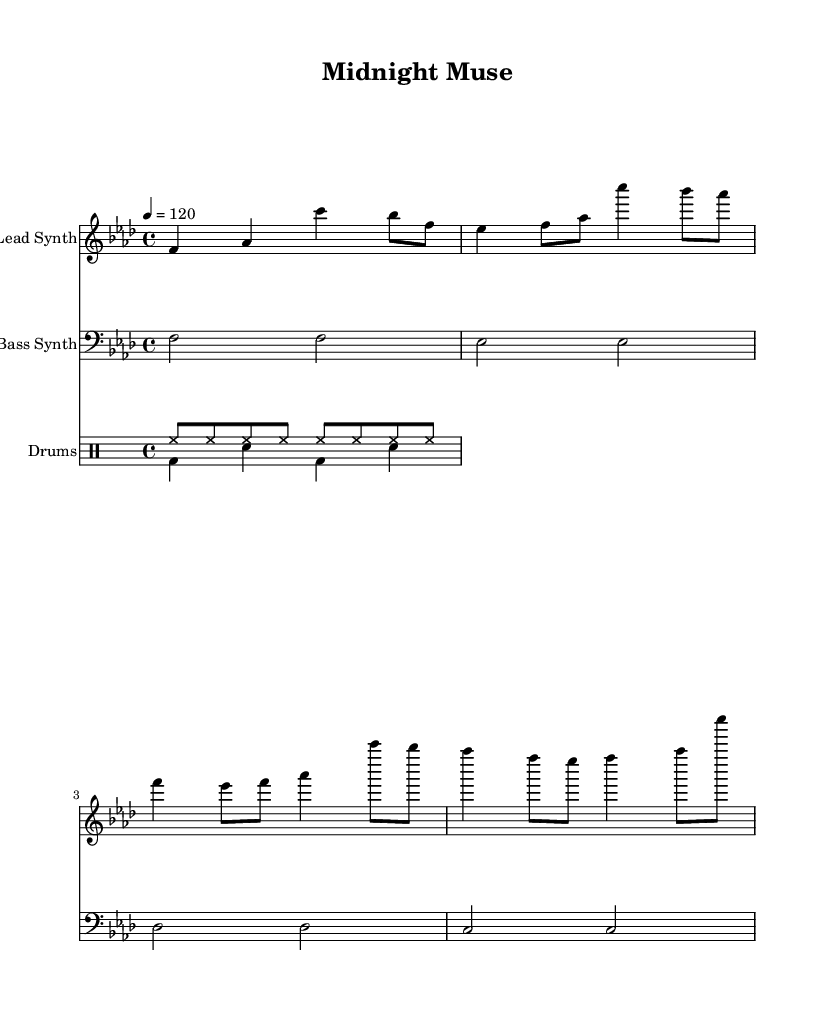what is the key signature of this music? The key signature indicates that the piece is in F minor, as it has four flats. These flats represent B flat, E flat, A flat, and D flat. F minor specifically has these flats in its key signature.
Answer: F minor what is the time signature of this music? The time signature is indicated as 4/4, which means there are four beats in each measure and the quarter note receives one beat. This is typical for disco music and facilitates a steady rhythm.
Answer: 4/4 what is the tempo marking for this piece? The tempo marking is given as 120 beats per minute, as indicated by the tempo marking at the start of the score. This denotes how quickly the piece should be played.
Answer: 120 how many measures are there in the lead synth line? By counting the distinct groups of notes separated by bar lines in the lead synth staff, we find there are a total of eight measures. Each measure is counted as the area between the vertical lines.
Answer: 8 what type of synth is indicated as the bass synth? The bass synth is specified in the sheet music as having a 'Bass Synth' instrument name indicated at the beginning of its staff. This shows that it follows a lower pitch range suitable for bass lines.
Answer: Bass Synth what type of drums pattern is featured in the drum staff? The drum staff contains a combination of hi-hat (hh) and bass drum (bd) patterns, with snare (sn) hits provided as complements. The rhythmic pattern established by these instruments is characteristic of disco music.
Answer: Hi-hat and bass pattern what is a characteristic feature of the night's writing ambiance suggested by this music? The mysterious synth melodies, coupled with a steady tempo and lush sound textures typical of disco, create an atmospheric environment perfect for late-night creative work. The blend of these elements suggests a contemplative and engaging ambiance.
Answer: Atmospheric ambiance 